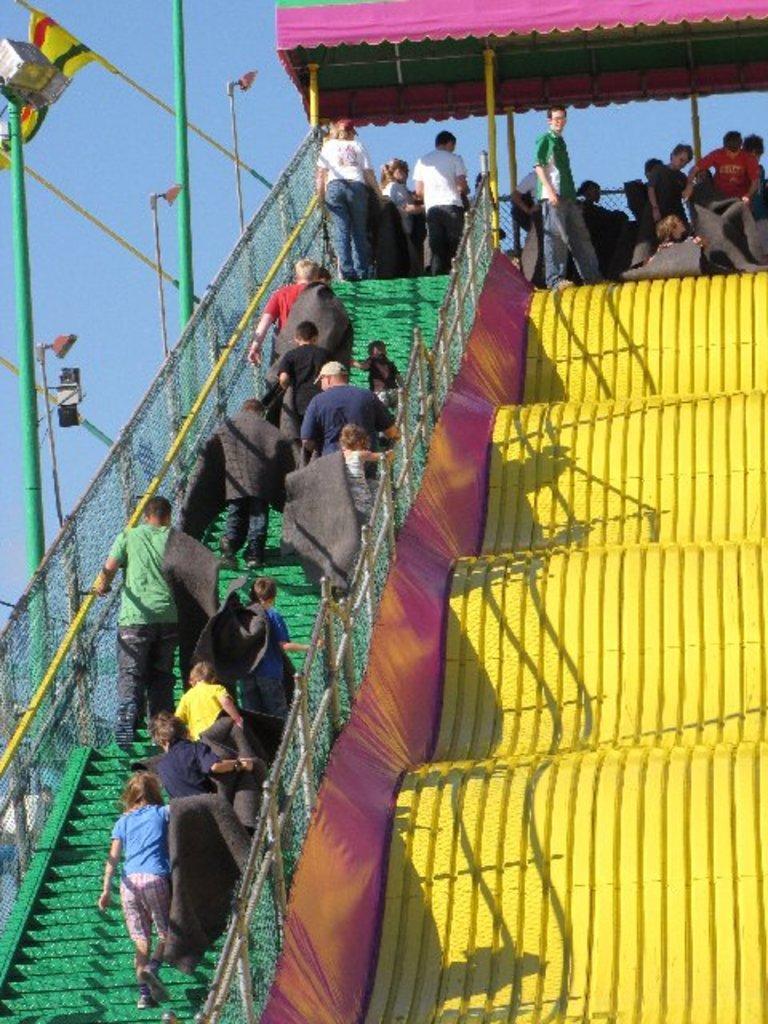Can you describe this image briefly? On the left side of the image we can see stairs, mesh, some persons, poles, lights are there. At the top of the image we can see tent, sky are there. On the right side of the image slides are there. 